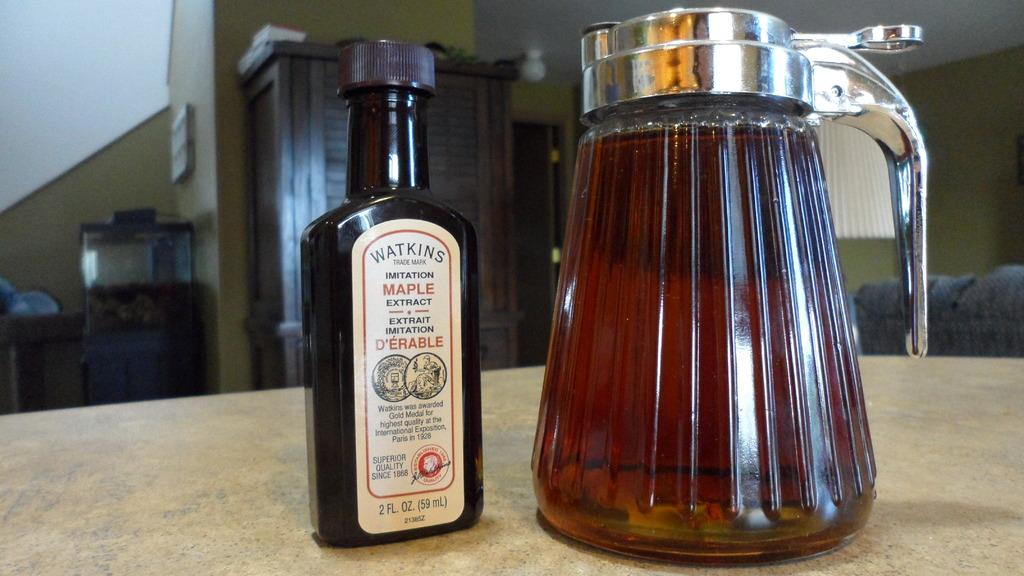Provide a one-sentence caption for the provided image. A bottle of Watkins maple extract next to a syrup container. 